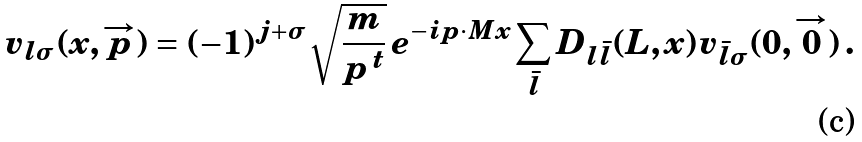<formula> <loc_0><loc_0><loc_500><loc_500>v _ { l \sigma } ( x , { \overrightarrow { p } } ) = ( - 1 ) ^ { j + \sigma } \sqrt { \frac { m } { p ^ { \, t } } } \, e ^ { - i p \cdot M x } \sum _ { \bar { l } } D _ { l \bar { l } } ( L , x ) v _ { \bar { l } \sigma } ( 0 , { \overrightarrow { 0 } } ) \, .</formula> 